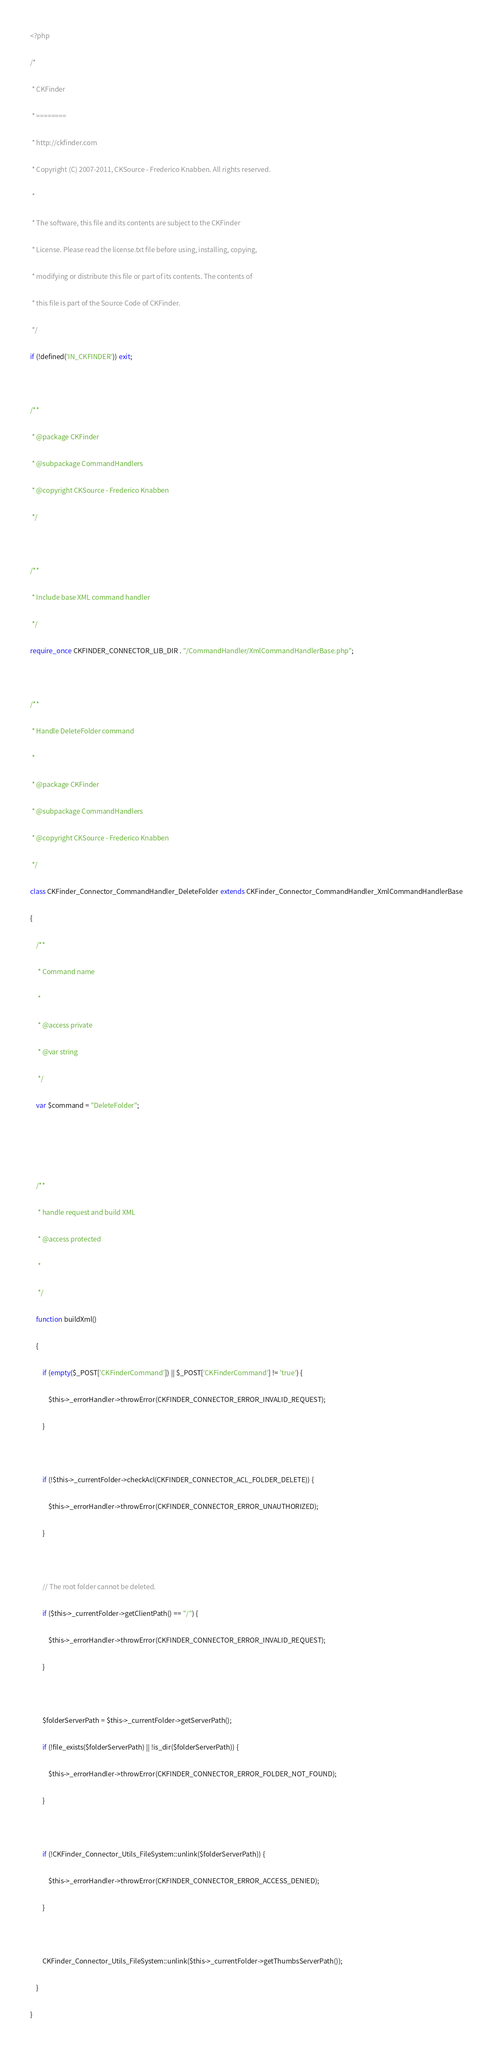<code> <loc_0><loc_0><loc_500><loc_500><_PHP_><?php
/*
 * CKFinder
 * ========
 * http://ckfinder.com
 * Copyright (C) 2007-2011, CKSource - Frederico Knabben. All rights reserved.
 *
 * The software, this file and its contents are subject to the CKFinder
 * License. Please read the license.txt file before using, installing, copying,
 * modifying or distribute this file or part of its contents. The contents of
 * this file is part of the Source Code of CKFinder.
 */
if (!defined('IN_CKFINDER')) exit;

/**
 * @package CKFinder
 * @subpackage CommandHandlers
 * @copyright CKSource - Frederico Knabben
 */

/**
 * Include base XML command handler
 */
require_once CKFINDER_CONNECTOR_LIB_DIR . "/CommandHandler/XmlCommandHandlerBase.php";

/**
 * Handle DeleteFolder command
 *
 * @package CKFinder
 * @subpackage CommandHandlers
 * @copyright CKSource - Frederico Knabben
 */
class CKFinder_Connector_CommandHandler_DeleteFolder extends CKFinder_Connector_CommandHandler_XmlCommandHandlerBase
{
    /**
     * Command name
     *
     * @access private
     * @var string
     */
    var $command = "DeleteFolder";


    /**
     * handle request and build XML
     * @access protected
     *
     */
    function buildXml()
    {
        if (empty($_POST['CKFinderCommand']) || $_POST['CKFinderCommand'] != 'true') {
            $this->_errorHandler->throwError(CKFINDER_CONNECTOR_ERROR_INVALID_REQUEST);
        }

        if (!$this->_currentFolder->checkAcl(CKFINDER_CONNECTOR_ACL_FOLDER_DELETE)) {
            $this->_errorHandler->throwError(CKFINDER_CONNECTOR_ERROR_UNAUTHORIZED);
        }

        // The root folder cannot be deleted.
        if ($this->_currentFolder->getClientPath() == "/") {
            $this->_errorHandler->throwError(CKFINDER_CONNECTOR_ERROR_INVALID_REQUEST);
        }

        $folderServerPath = $this->_currentFolder->getServerPath();
        if (!file_exists($folderServerPath) || !is_dir($folderServerPath)) {
            $this->_errorHandler->throwError(CKFINDER_CONNECTOR_ERROR_FOLDER_NOT_FOUND);
        }

        if (!CKFinder_Connector_Utils_FileSystem::unlink($folderServerPath)) {
            $this->_errorHandler->throwError(CKFINDER_CONNECTOR_ERROR_ACCESS_DENIED);
        }

        CKFinder_Connector_Utils_FileSystem::unlink($this->_currentFolder->getThumbsServerPath());
    }
}
</code> 